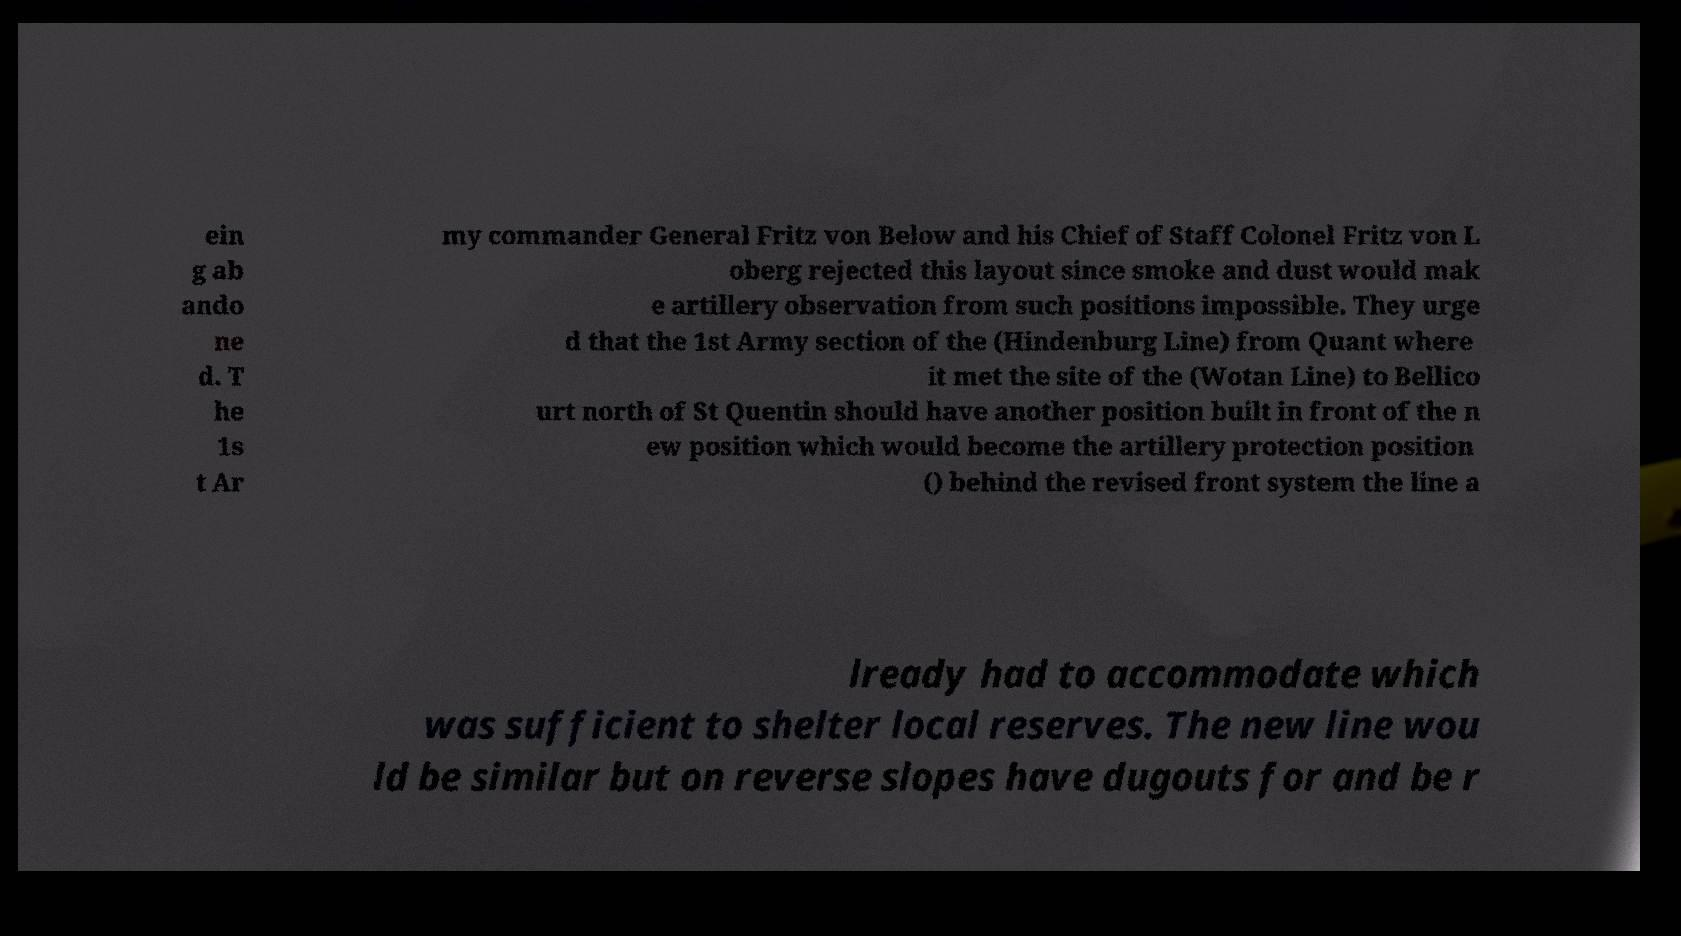What messages or text are displayed in this image? I need them in a readable, typed format. ein g ab ando ne d. T he 1s t Ar my commander General Fritz von Below and his Chief of Staff Colonel Fritz von L oberg rejected this layout since smoke and dust would mak e artillery observation from such positions impossible. They urge d that the 1st Army section of the (Hindenburg Line) from Quant where it met the site of the (Wotan Line) to Bellico urt north of St Quentin should have another position built in front of the n ew position which would become the artillery protection position () behind the revised front system the line a lready had to accommodate which was sufficient to shelter local reserves. The new line wou ld be similar but on reverse slopes have dugouts for and be r 